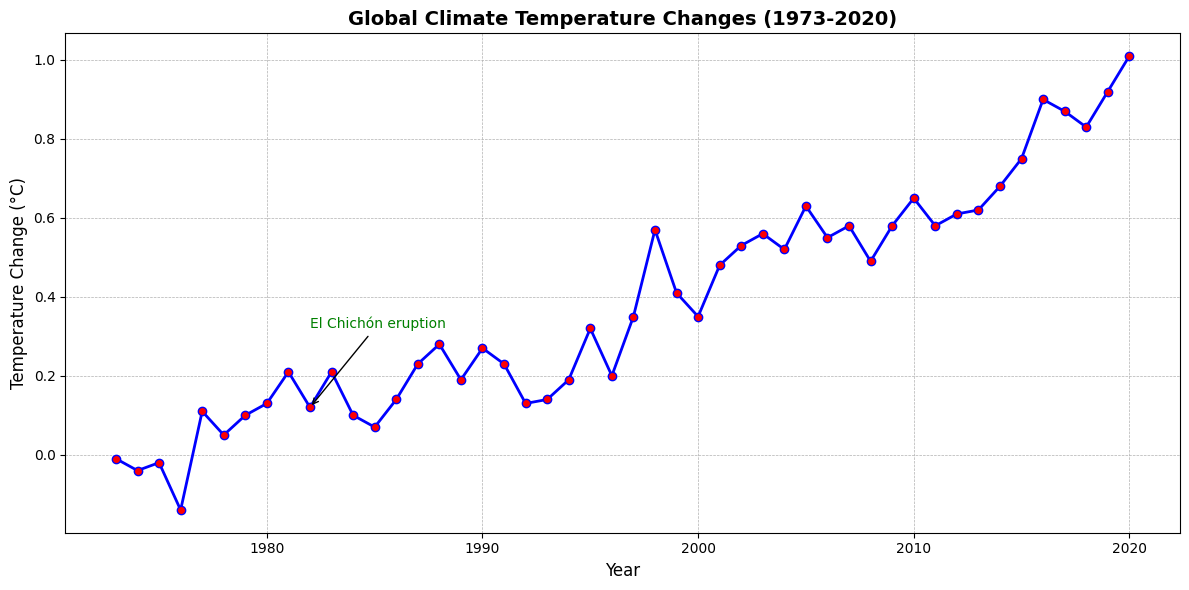What event is annotated in the figure? The figure shows text annotation near specific data points. Identify the text provided next to one of these data points.
Answer: El Chichón eruption What was the global temperature change in the year of the El Chichón eruption? Find the year related to the El Chichón eruption annotation in the figure and read the corresponding temperature change value.
Answer: 0.12°C How much did the global temperature change from 1976 to 2010? Find the temperature change value for 1976 (-0.14°C) and 2010 (0.65°C) and calculate the difference: 0.65 - (-0.14).
Answer: 0.79°C Which year had the highest global temperature change in the plot? Identify the data point with the highest vertical position (temperature value) on the y-axis.
Answer: 2020 Comparing the El Niño years (1998, 2010, 2016), which one had the highest temperature change? Locate the temperature change values for the years 1998 (0.57°C), 2010 (0.65°C), and 2016 (0.90°C) and compare them.
Answer: 2016 What is the global temperature change trend over the past 50 years? Observe the overall pattern of the plotted line from left (1973) to right (2020). Describe whether the line is ascending, descending, or fluctuating.
Answer: Ascending What was the global temperature change in the year just after the Mount Pinatubo eruption? Identify the year of the Mount Pinatubo eruption (1991) and check the temperature change value for the following year (1992).
Answer: 0.13°C How many years saw a temperature change of 0.5°C or higher? Count the number of years where the temperature change values reach or surpass 0.5°C.
Answer: 7 Between which two consecutive years did the global temperature change show the largest increase? Calculate the year-over-year differences and identify the pair of years with the largest positive difference.
Answer: 2015 to 2016 By how much did the global temperature change from 1998 to 1999, the year following the Strong El Niño event? Find the temperature change values for 1998 (0.57°C) and 1999 (0.41°C), and calculate the difference: 0.57 - 0.41.
Answer: -0.16°C 